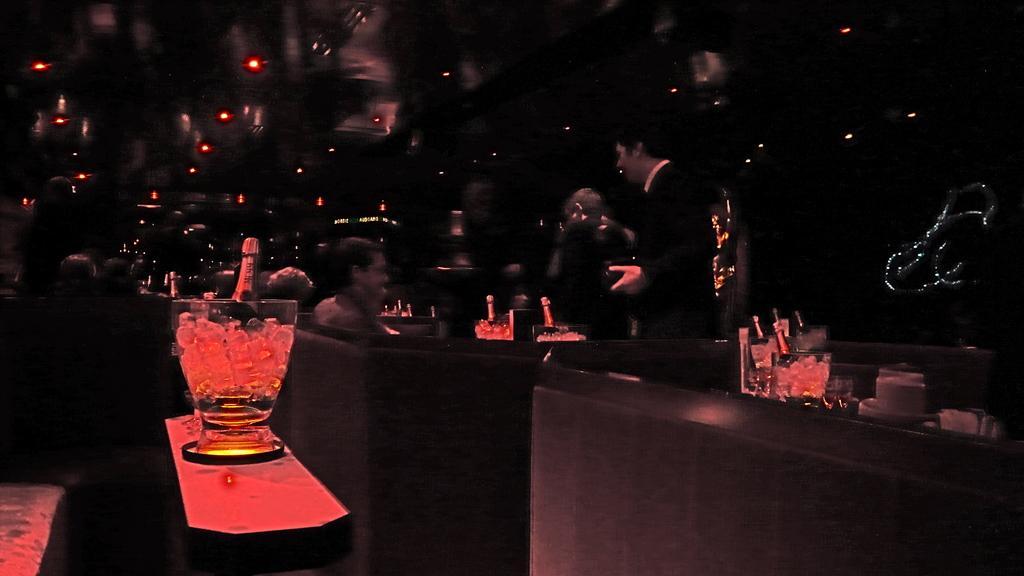Describe this image in one or two sentences. In this image I can see a person wearing white shirt and black blazer is standing and another person is sitting on a couch and I can see a table, a glass beaker on a table and in the beaker I can see few ice cubes and a wine bottle. I can see number of beakers with ice cubes and wine bottles in them and I can see the dark background. 